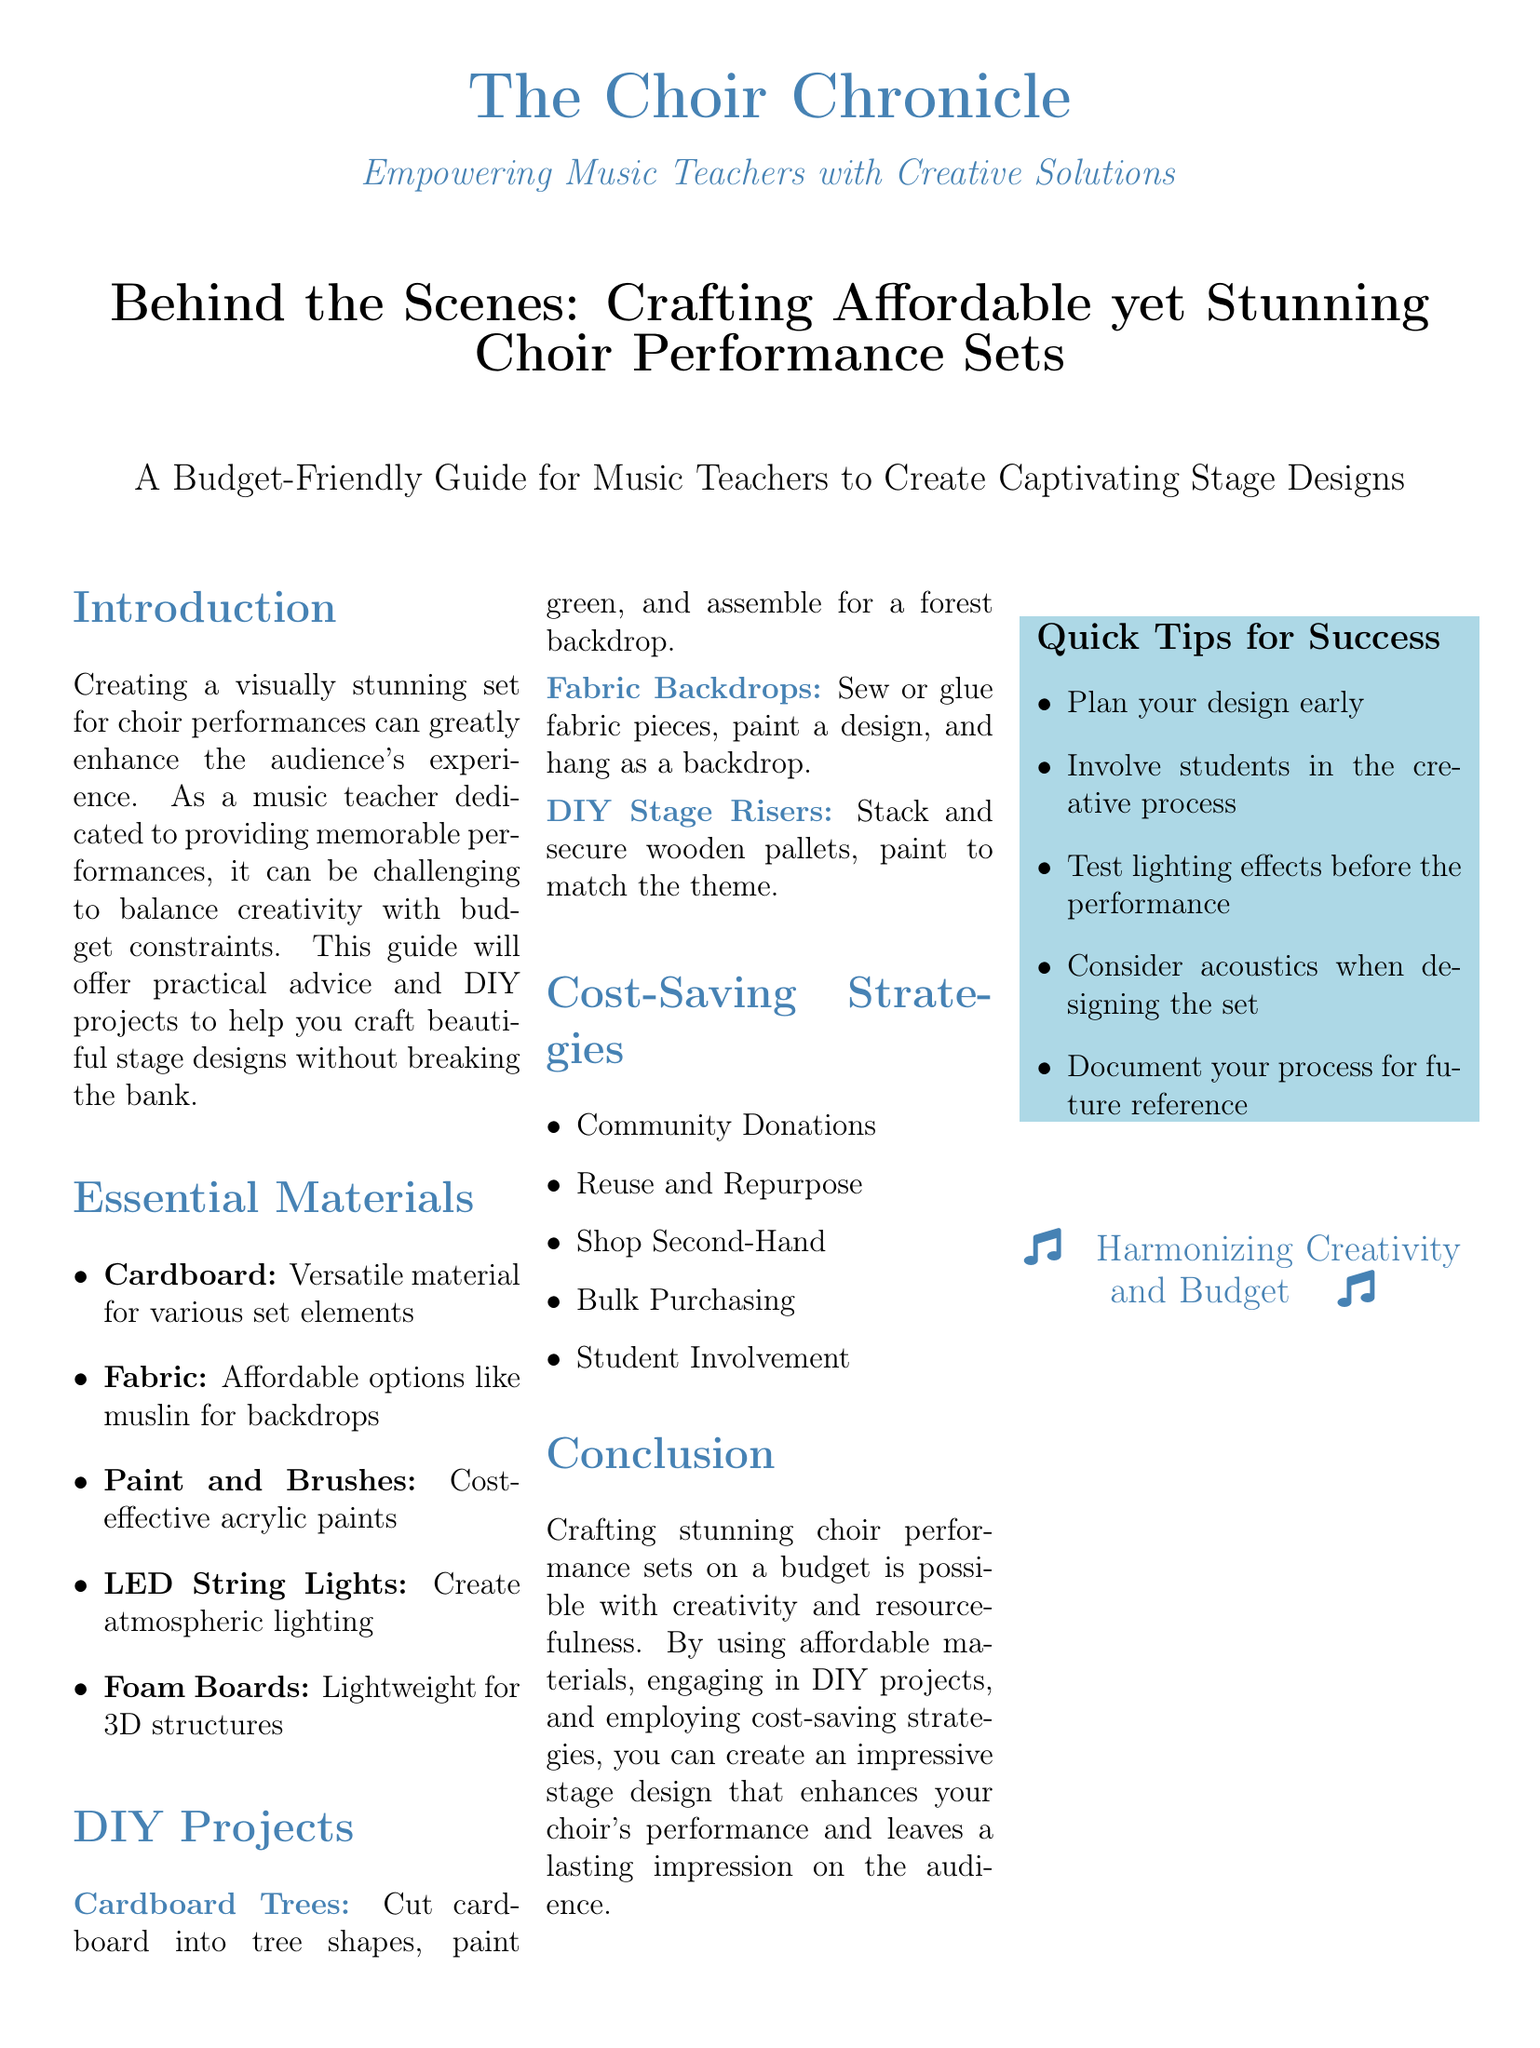What is the title of the article? The title is a prominent element of the document, found near the top, capturing the main theme.
Answer: Behind the Scenes: Crafting Affordable yet Stunning Choir Performance Sets What is one essential material listed for set creation? The document outlines various materials crucial for crafting sets, specifically highlighting affordable options.
Answer: Cardboard How many DIY projects are mentioned? The document lists specific DIY projects under a dedicated section for easy reference and organization.
Answer: 3 What is one cost-saving strategy suggested? The article provides practical strategies to help manage expenses, ensuring successful set creation on a budget.
Answer: Community Donations What color is used for section headings in the document? The document specifies a color to distinguish section titles, enhancing visual appeal and organization.
Answer: Music blue What should be tested before the performance? This recommendation is part of the quick tips for success, ensuring a smooth experience during the show.
Answer: Lighting effects What does the guide suggest to involve students in? The document emphasizes engagement and collaboration as part of the set design process, promoting creativity.
Answer: The creative process How many quick tips are provided? The quick tips section includes concise advice to help music teachers succeed in their set designs.
Answer: 5 